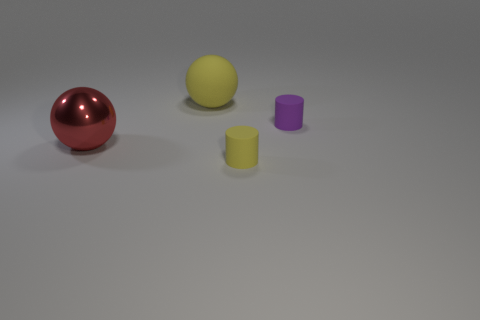Add 4 matte spheres. How many objects exist? 8 Add 4 shiny things. How many shiny things exist? 5 Subtract 0 gray blocks. How many objects are left? 4 Subtract all large matte blocks. Subtract all tiny yellow cylinders. How many objects are left? 3 Add 1 tiny yellow rubber cylinders. How many tiny yellow rubber cylinders are left? 2 